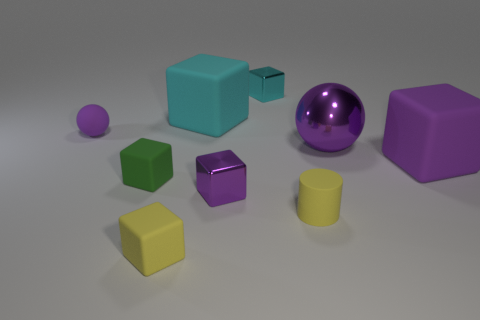What material is the large cube that is the same color as the metallic ball?
Keep it short and to the point. Rubber. Is the small purple ball made of the same material as the tiny cylinder?
Provide a succinct answer. Yes. What number of big things are to the right of the big purple object behind the rubber thing that is on the right side of the tiny cylinder?
Provide a succinct answer. 1. Are there any tiny green cubes made of the same material as the small sphere?
Ensure brevity in your answer.  Yes. What is the size of the sphere that is the same color as the large shiny thing?
Ensure brevity in your answer.  Small. Are there fewer purple metallic blocks than large blue shiny blocks?
Provide a short and direct response. No. Do the small cube behind the green thing and the metal ball have the same color?
Offer a terse response. No. There is a large block that is to the left of the tiny purple object in front of the large matte object on the right side of the small cyan shiny cube; what is it made of?
Make the answer very short. Rubber. Is there a shiny cube of the same color as the large ball?
Keep it short and to the point. Yes. Is the number of tiny purple shiny blocks that are in front of the tiny yellow block less than the number of green objects?
Give a very brief answer. Yes. 